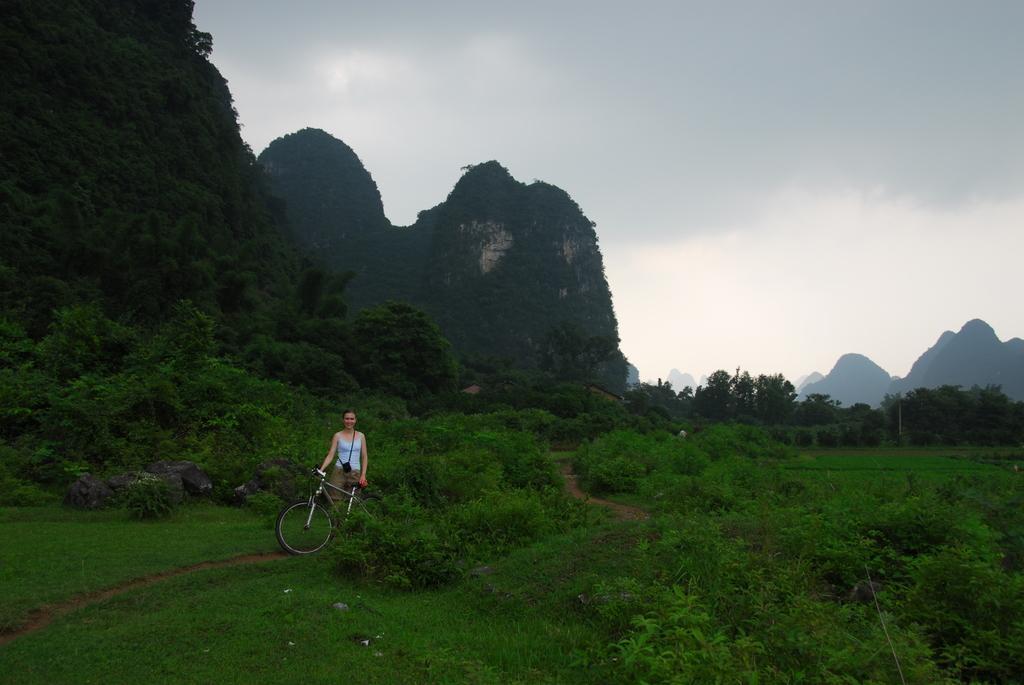Please provide a concise description of this image. In this image we can see a lady holding a cycle. On the ground there are plants and trees. Also there are rocks. In the back there are hills and sky with clouds. 